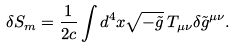<formula> <loc_0><loc_0><loc_500><loc_500>\delta S _ { m } = \frac { 1 } { 2 c } \int d ^ { 4 } x \sqrt { - \tilde { g } } \, T _ { \mu \nu } \delta \tilde { g } ^ { \mu \nu } .</formula> 